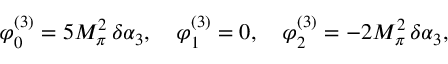<formula> <loc_0><loc_0><loc_500><loc_500>\varphi _ { 0 } ^ { ( 3 ) } = 5 M _ { \pi } ^ { 2 } \, \delta \alpha _ { 3 } , \varphi _ { 1 } ^ { ( 3 ) } = 0 , \varphi _ { 2 } ^ { ( 3 ) } = - 2 M _ { \pi } ^ { 2 } \, \delta \alpha _ { 3 } ,</formula> 